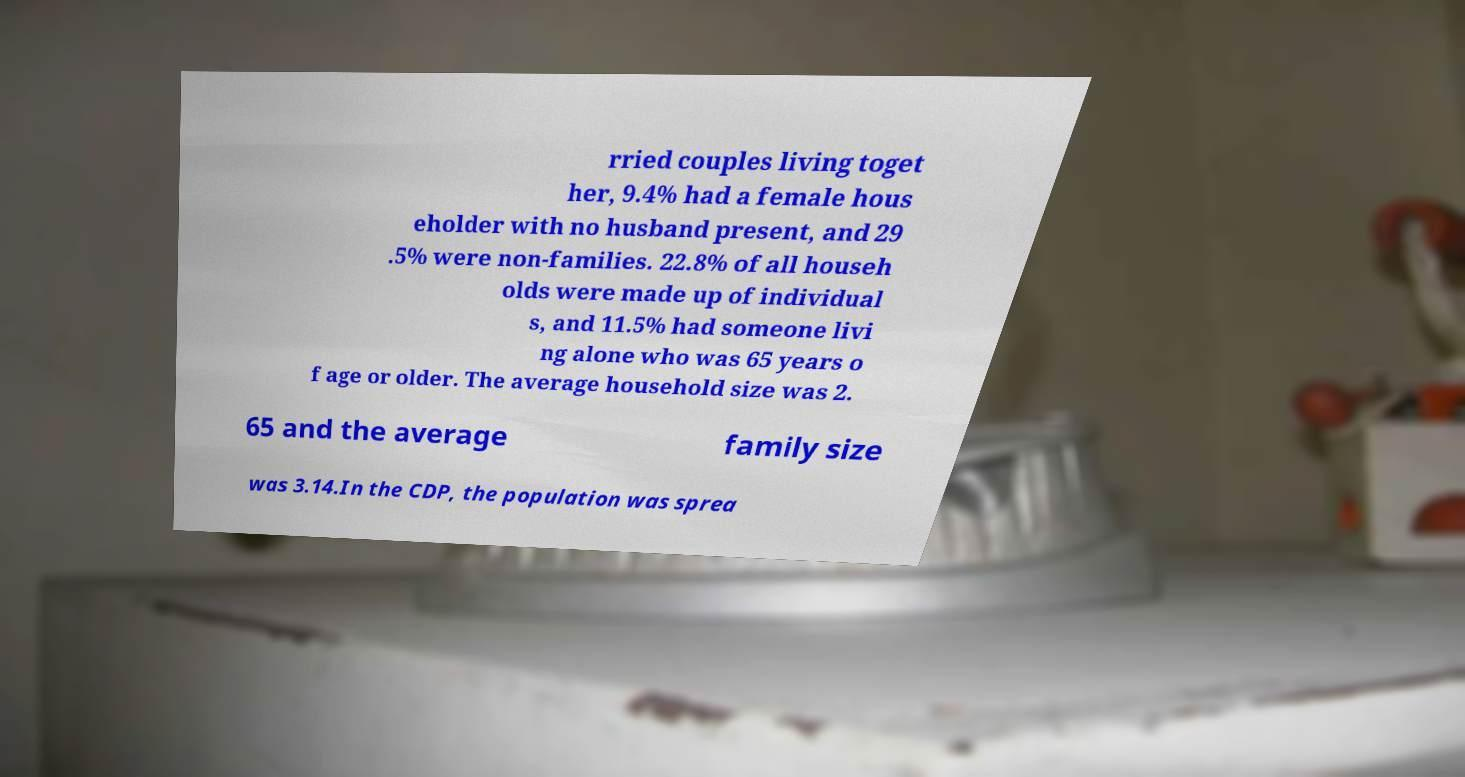Could you extract and type out the text from this image? rried couples living toget her, 9.4% had a female hous eholder with no husband present, and 29 .5% were non-families. 22.8% of all househ olds were made up of individual s, and 11.5% had someone livi ng alone who was 65 years o f age or older. The average household size was 2. 65 and the average family size was 3.14.In the CDP, the population was sprea 